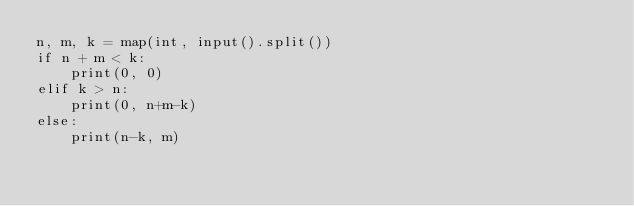Convert code to text. <code><loc_0><loc_0><loc_500><loc_500><_Python_>n, m, k = map(int, input().split())
if n + m < k:
    print(0, 0)
elif k > n:
    print(0, n+m-k)
else:
    print(n-k, m)
    </code> 